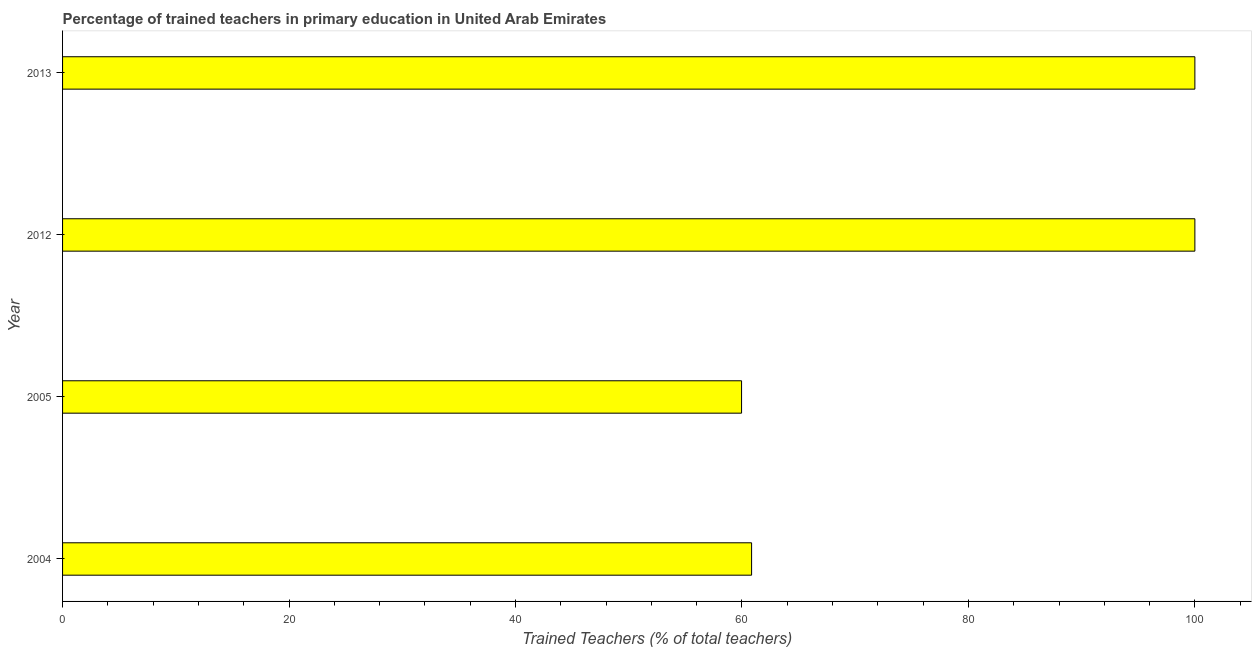Does the graph contain grids?
Ensure brevity in your answer.  No. What is the title of the graph?
Ensure brevity in your answer.  Percentage of trained teachers in primary education in United Arab Emirates. What is the label or title of the X-axis?
Keep it short and to the point. Trained Teachers (% of total teachers). What is the label or title of the Y-axis?
Ensure brevity in your answer.  Year. Across all years, what is the minimum percentage of trained teachers?
Your response must be concise. 59.97. In which year was the percentage of trained teachers maximum?
Make the answer very short. 2012. What is the sum of the percentage of trained teachers?
Your answer should be compact. 320.82. What is the difference between the percentage of trained teachers in 2004 and 2013?
Your answer should be very brief. -39.15. What is the average percentage of trained teachers per year?
Offer a terse response. 80.2. What is the median percentage of trained teachers?
Keep it short and to the point. 80.43. In how many years, is the percentage of trained teachers greater than 72 %?
Your answer should be compact. 2. Do a majority of the years between 2013 and 2004 (inclusive) have percentage of trained teachers greater than 88 %?
Keep it short and to the point. Yes. What is the ratio of the percentage of trained teachers in 2005 to that in 2013?
Your response must be concise. 0.6. Is the difference between the percentage of trained teachers in 2005 and 2013 greater than the difference between any two years?
Offer a very short reply. Yes. What is the difference between the highest and the second highest percentage of trained teachers?
Give a very brief answer. 0. Is the sum of the percentage of trained teachers in 2004 and 2013 greater than the maximum percentage of trained teachers across all years?
Your response must be concise. Yes. What is the difference between the highest and the lowest percentage of trained teachers?
Offer a very short reply. 40.03. In how many years, is the percentage of trained teachers greater than the average percentage of trained teachers taken over all years?
Provide a short and direct response. 2. How many bars are there?
Provide a short and direct response. 4. How many years are there in the graph?
Your response must be concise. 4. What is the difference between two consecutive major ticks on the X-axis?
Provide a succinct answer. 20. Are the values on the major ticks of X-axis written in scientific E-notation?
Offer a terse response. No. What is the Trained Teachers (% of total teachers) in 2004?
Provide a short and direct response. 60.85. What is the Trained Teachers (% of total teachers) of 2005?
Ensure brevity in your answer.  59.97. What is the Trained Teachers (% of total teachers) of 2013?
Your answer should be compact. 100. What is the difference between the Trained Teachers (% of total teachers) in 2004 and 2005?
Provide a short and direct response. 0.89. What is the difference between the Trained Teachers (% of total teachers) in 2004 and 2012?
Provide a short and direct response. -39.15. What is the difference between the Trained Teachers (% of total teachers) in 2004 and 2013?
Ensure brevity in your answer.  -39.15. What is the difference between the Trained Teachers (% of total teachers) in 2005 and 2012?
Your response must be concise. -40.03. What is the difference between the Trained Teachers (% of total teachers) in 2005 and 2013?
Your response must be concise. -40.03. What is the difference between the Trained Teachers (% of total teachers) in 2012 and 2013?
Provide a succinct answer. 0. What is the ratio of the Trained Teachers (% of total teachers) in 2004 to that in 2012?
Keep it short and to the point. 0.61. What is the ratio of the Trained Teachers (% of total teachers) in 2004 to that in 2013?
Offer a very short reply. 0.61. 